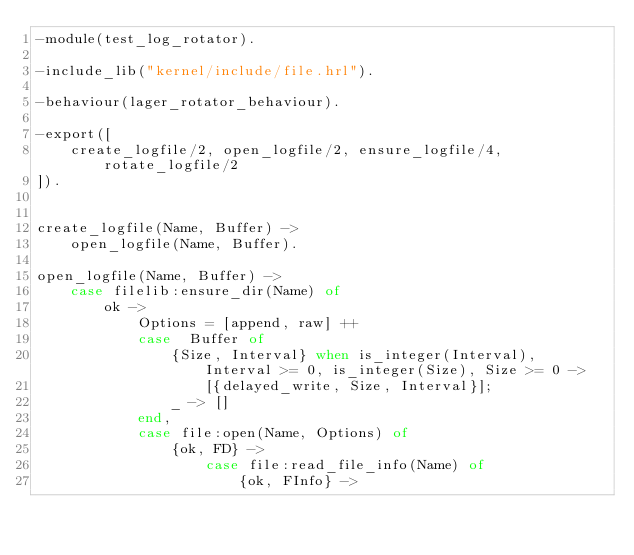<code> <loc_0><loc_0><loc_500><loc_500><_Erlang_>-module(test_log_rotator).

-include_lib("kernel/include/file.hrl").

-behaviour(lager_rotator_behaviour).

-export([
    create_logfile/2, open_logfile/2, ensure_logfile/4, rotate_logfile/2
]).


create_logfile(Name, Buffer) ->
    open_logfile(Name, Buffer).

open_logfile(Name, Buffer) ->
    case filelib:ensure_dir(Name) of
        ok ->
            Options = [append, raw] ++
            case  Buffer of
                {Size, Interval} when is_integer(Interval), Interval >= 0, is_integer(Size), Size >= 0 ->
                    [{delayed_write, Size, Interval}];
                _ -> []
            end,
            case file:open(Name, Options) of
                {ok, FD} ->
                    case file:read_file_info(Name) of
                        {ok, FInfo} -></code> 